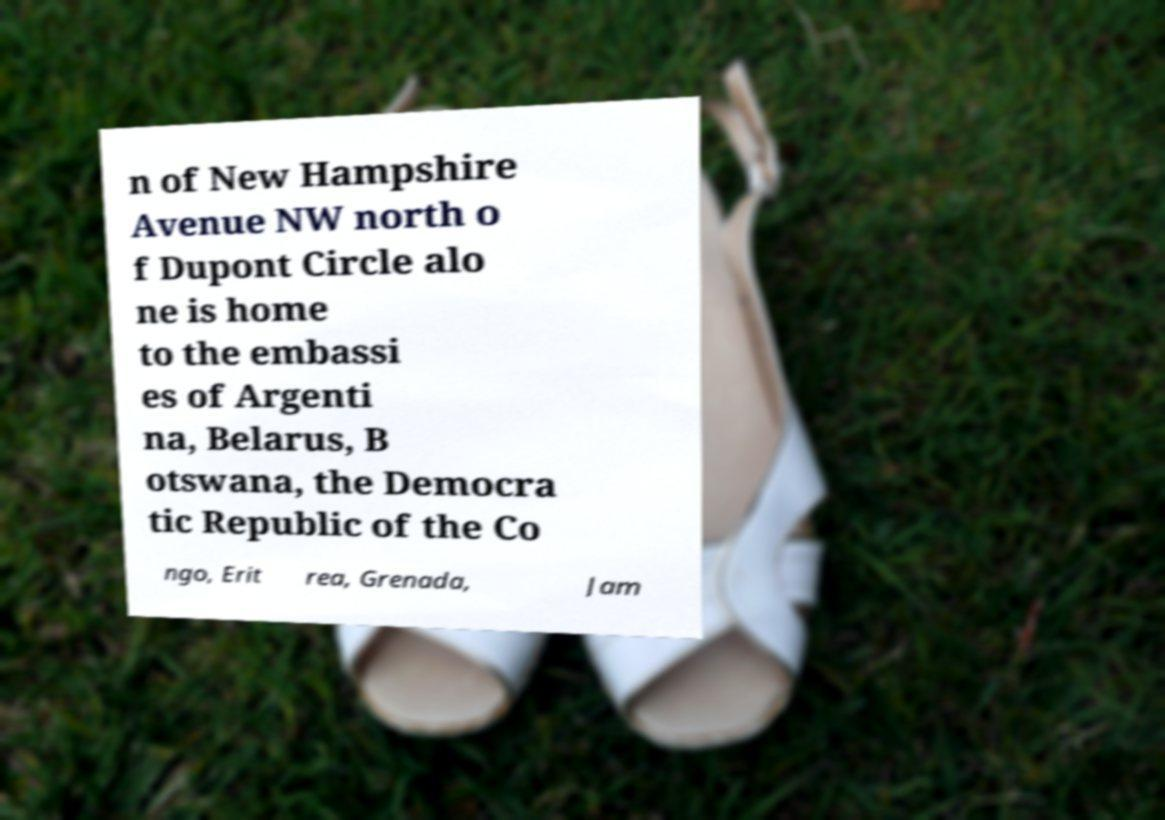There's text embedded in this image that I need extracted. Can you transcribe it verbatim? n of New Hampshire Avenue NW north o f Dupont Circle alo ne is home to the embassi es of Argenti na, Belarus, B otswana, the Democra tic Republic of the Co ngo, Erit rea, Grenada, Jam 